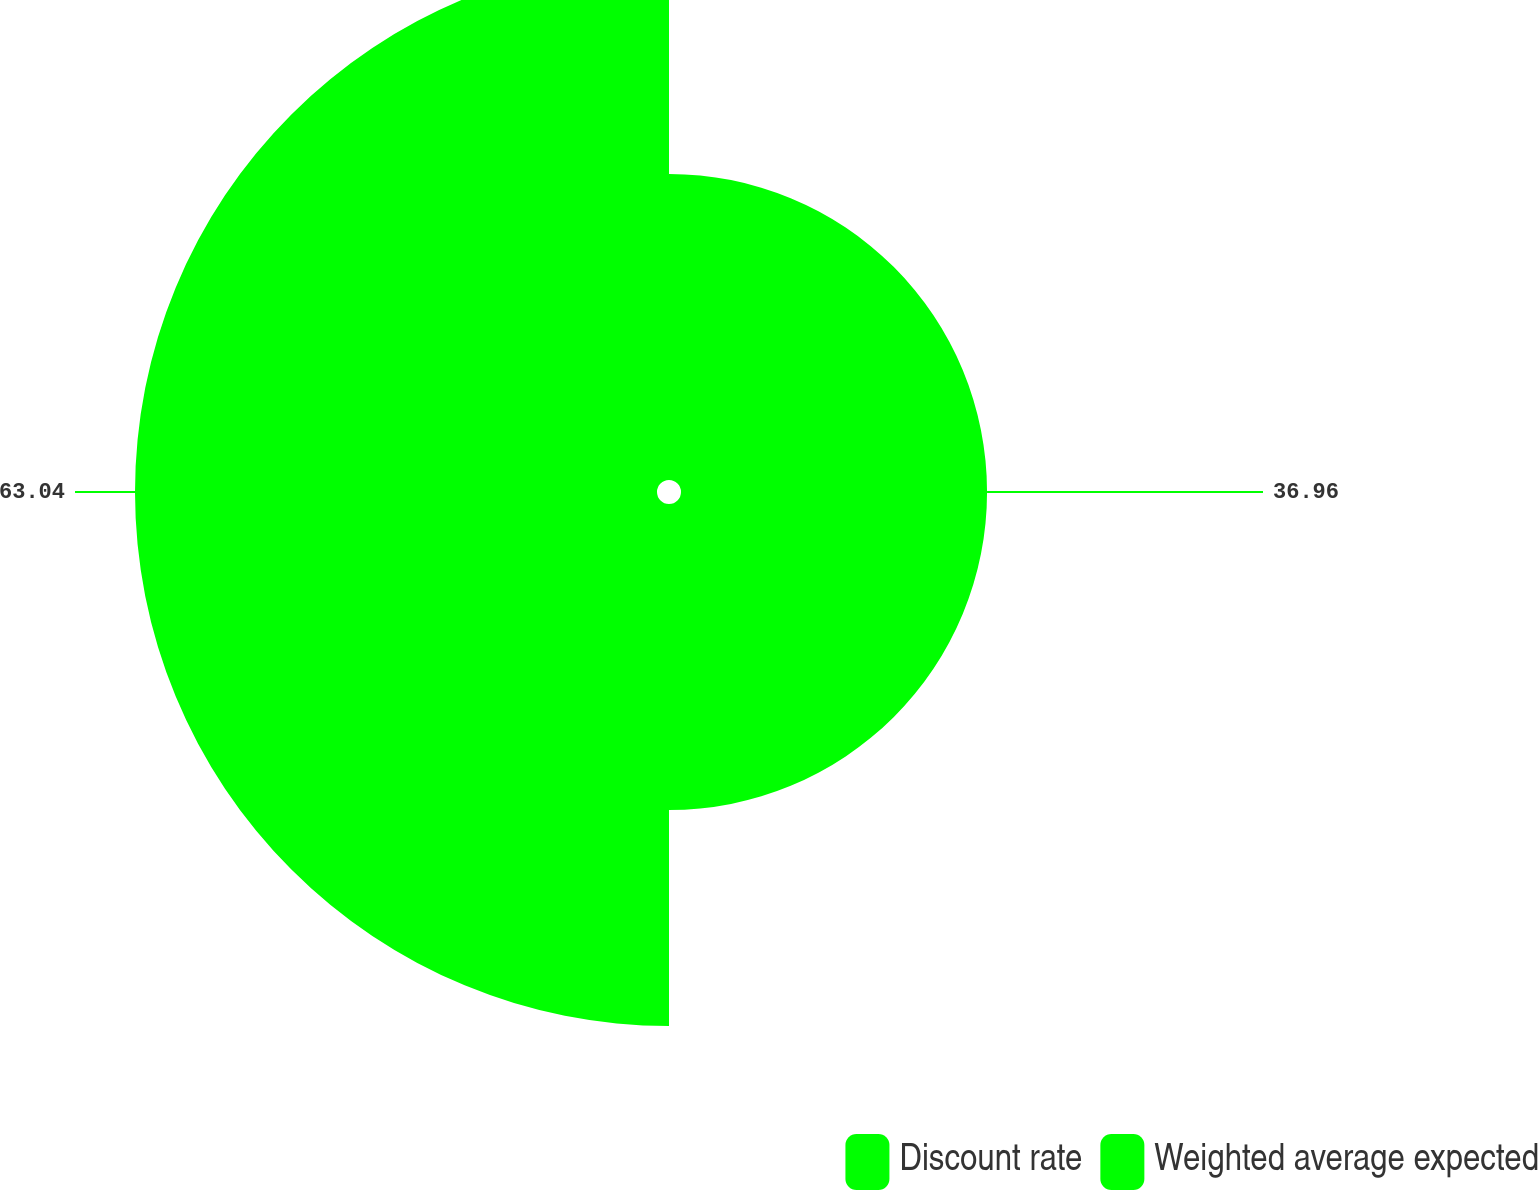<chart> <loc_0><loc_0><loc_500><loc_500><pie_chart><fcel>Discount rate<fcel>Weighted average expected<nl><fcel>36.96%<fcel>63.04%<nl></chart> 